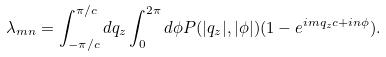Convert formula to latex. <formula><loc_0><loc_0><loc_500><loc_500>\lambda _ { m n } = \int _ { - \pi / c } ^ { \pi / c } d q _ { z } \int _ { 0 } ^ { 2 \pi } d \phi P ( | q _ { z } | , | \phi | ) ( 1 - e ^ { i m q _ { z } c + i n \phi } ) .</formula> 